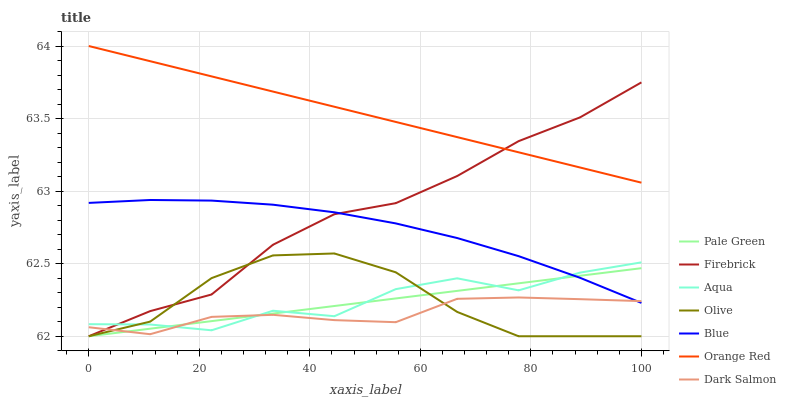Does Dark Salmon have the minimum area under the curve?
Answer yes or no. Yes. Does Orange Red have the maximum area under the curve?
Answer yes or no. Yes. Does Firebrick have the minimum area under the curve?
Answer yes or no. No. Does Firebrick have the maximum area under the curve?
Answer yes or no. No. Is Pale Green the smoothest?
Answer yes or no. Yes. Is Aqua the roughest?
Answer yes or no. Yes. Is Firebrick the smoothest?
Answer yes or no. No. Is Firebrick the roughest?
Answer yes or no. No. Does Aqua have the lowest value?
Answer yes or no. No. Does Firebrick have the highest value?
Answer yes or no. No. Is Pale Green less than Orange Red?
Answer yes or no. Yes. Is Orange Red greater than Olive?
Answer yes or no. Yes. Does Pale Green intersect Orange Red?
Answer yes or no. No. 